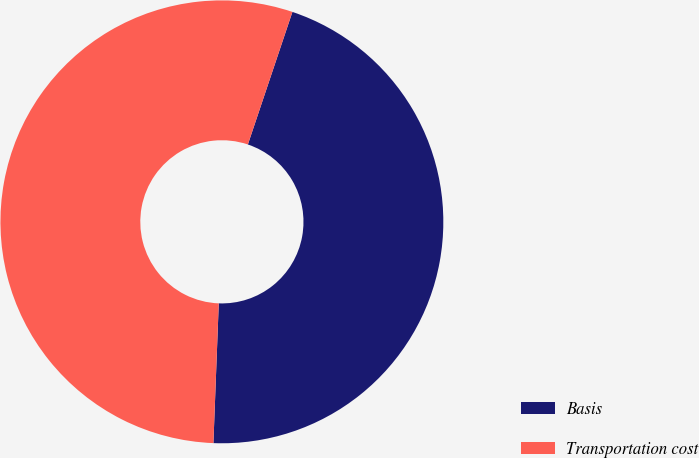Convert chart. <chart><loc_0><loc_0><loc_500><loc_500><pie_chart><fcel>Basis<fcel>Transportation cost<nl><fcel>45.45%<fcel>54.55%<nl></chart> 